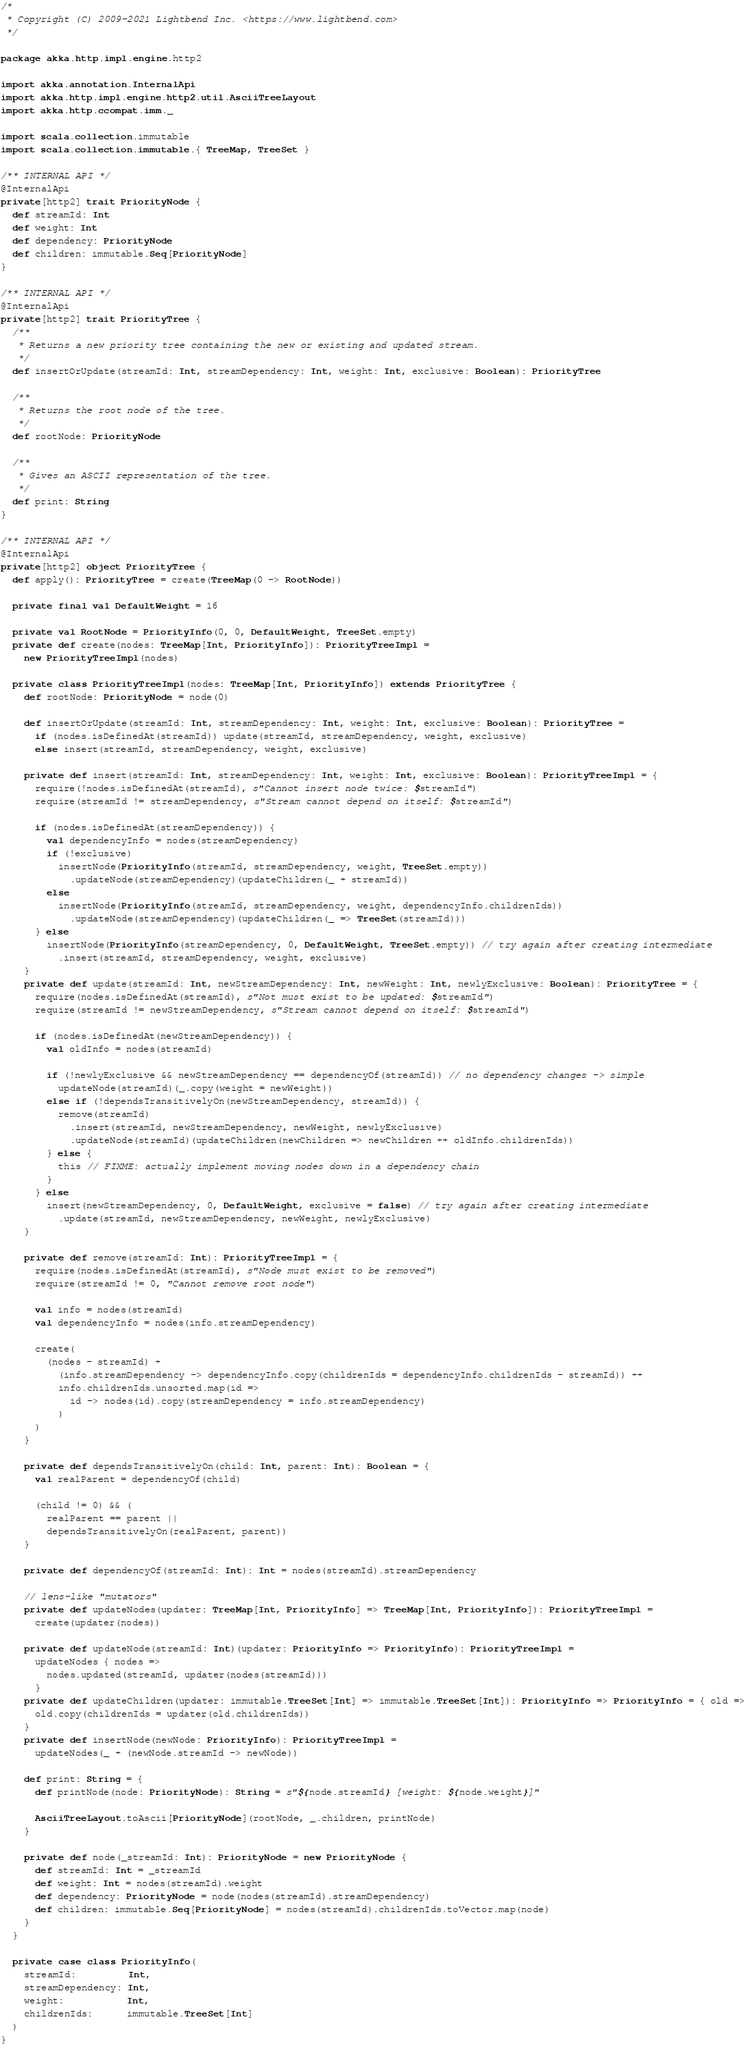<code> <loc_0><loc_0><loc_500><loc_500><_Scala_>/*
 * Copyright (C) 2009-2021 Lightbend Inc. <https://www.lightbend.com>
 */

package akka.http.impl.engine.http2

import akka.annotation.InternalApi
import akka.http.impl.engine.http2.util.AsciiTreeLayout
import akka.http.ccompat.imm._

import scala.collection.immutable
import scala.collection.immutable.{ TreeMap, TreeSet }

/** INTERNAL API */
@InternalApi
private[http2] trait PriorityNode {
  def streamId: Int
  def weight: Int
  def dependency: PriorityNode
  def children: immutable.Seq[PriorityNode]
}

/** INTERNAL API */
@InternalApi
private[http2] trait PriorityTree {
  /**
   * Returns a new priority tree containing the new or existing and updated stream.
   */
  def insertOrUpdate(streamId: Int, streamDependency: Int, weight: Int, exclusive: Boolean): PriorityTree

  /**
   * Returns the root node of the tree.
   */
  def rootNode: PriorityNode

  /**
   * Gives an ASCII representation of the tree.
   */
  def print: String
}

/** INTERNAL API */
@InternalApi
private[http2] object PriorityTree {
  def apply(): PriorityTree = create(TreeMap(0 -> RootNode))

  private final val DefaultWeight = 16

  private val RootNode = PriorityInfo(0, 0, DefaultWeight, TreeSet.empty)
  private def create(nodes: TreeMap[Int, PriorityInfo]): PriorityTreeImpl =
    new PriorityTreeImpl(nodes)

  private class PriorityTreeImpl(nodes: TreeMap[Int, PriorityInfo]) extends PriorityTree {
    def rootNode: PriorityNode = node(0)

    def insertOrUpdate(streamId: Int, streamDependency: Int, weight: Int, exclusive: Boolean): PriorityTree =
      if (nodes.isDefinedAt(streamId)) update(streamId, streamDependency, weight, exclusive)
      else insert(streamId, streamDependency, weight, exclusive)

    private def insert(streamId: Int, streamDependency: Int, weight: Int, exclusive: Boolean): PriorityTreeImpl = {
      require(!nodes.isDefinedAt(streamId), s"Cannot insert node twice: $streamId")
      require(streamId != streamDependency, s"Stream cannot depend on itself: $streamId")

      if (nodes.isDefinedAt(streamDependency)) {
        val dependencyInfo = nodes(streamDependency)
        if (!exclusive)
          insertNode(PriorityInfo(streamId, streamDependency, weight, TreeSet.empty))
            .updateNode(streamDependency)(updateChildren(_ + streamId))
        else
          insertNode(PriorityInfo(streamId, streamDependency, weight, dependencyInfo.childrenIds))
            .updateNode(streamDependency)(updateChildren(_ => TreeSet(streamId)))
      } else
        insertNode(PriorityInfo(streamDependency, 0, DefaultWeight, TreeSet.empty)) // try again after creating intermediate
          .insert(streamId, streamDependency, weight, exclusive)
    }
    private def update(streamId: Int, newStreamDependency: Int, newWeight: Int, newlyExclusive: Boolean): PriorityTree = {
      require(nodes.isDefinedAt(streamId), s"Not must exist to be updated: $streamId")
      require(streamId != newStreamDependency, s"Stream cannot depend on itself: $streamId")

      if (nodes.isDefinedAt(newStreamDependency)) {
        val oldInfo = nodes(streamId)

        if (!newlyExclusive && newStreamDependency == dependencyOf(streamId)) // no dependency changes -> simple
          updateNode(streamId)(_.copy(weight = newWeight))
        else if (!dependsTransitivelyOn(newStreamDependency, streamId)) {
          remove(streamId)
            .insert(streamId, newStreamDependency, newWeight, newlyExclusive)
            .updateNode(streamId)(updateChildren(newChildren => newChildren ++ oldInfo.childrenIds))
        } else {
          this // FIXME: actually implement moving nodes down in a dependency chain
        }
      } else
        insert(newStreamDependency, 0, DefaultWeight, exclusive = false) // try again after creating intermediate
          .update(streamId, newStreamDependency, newWeight, newlyExclusive)
    }

    private def remove(streamId: Int): PriorityTreeImpl = {
      require(nodes.isDefinedAt(streamId), s"Node must exist to be removed")
      require(streamId != 0, "Cannot remove root node")

      val info = nodes(streamId)
      val dependencyInfo = nodes(info.streamDependency)

      create(
        (nodes - streamId) +
          (info.streamDependency -> dependencyInfo.copy(childrenIds = dependencyInfo.childrenIds - streamId)) ++
          info.childrenIds.unsorted.map(id =>
            id -> nodes(id).copy(streamDependency = info.streamDependency)
          )
      )
    }

    private def dependsTransitivelyOn(child: Int, parent: Int): Boolean = {
      val realParent = dependencyOf(child)

      (child != 0) && (
        realParent == parent ||
        dependsTransitivelyOn(realParent, parent))
    }

    private def dependencyOf(streamId: Int): Int = nodes(streamId).streamDependency

    // lens-like "mutators"
    private def updateNodes(updater: TreeMap[Int, PriorityInfo] => TreeMap[Int, PriorityInfo]): PriorityTreeImpl =
      create(updater(nodes))

    private def updateNode(streamId: Int)(updater: PriorityInfo => PriorityInfo): PriorityTreeImpl =
      updateNodes { nodes =>
        nodes.updated(streamId, updater(nodes(streamId)))
      }
    private def updateChildren(updater: immutable.TreeSet[Int] => immutable.TreeSet[Int]): PriorityInfo => PriorityInfo = { old =>
      old.copy(childrenIds = updater(old.childrenIds))
    }
    private def insertNode(newNode: PriorityInfo): PriorityTreeImpl =
      updateNodes(_ + (newNode.streamId -> newNode))

    def print: String = {
      def printNode(node: PriorityNode): String = s"${node.streamId} [weight: ${node.weight}]"

      AsciiTreeLayout.toAscii[PriorityNode](rootNode, _.children, printNode)
    }

    private def node(_streamId: Int): PriorityNode = new PriorityNode {
      def streamId: Int = _streamId
      def weight: Int = nodes(streamId).weight
      def dependency: PriorityNode = node(nodes(streamId).streamDependency)
      def children: immutable.Seq[PriorityNode] = nodes(streamId).childrenIds.toVector.map(node)
    }
  }

  private case class PriorityInfo(
    streamId:         Int,
    streamDependency: Int,
    weight:           Int,
    childrenIds:      immutable.TreeSet[Int]
  )
}
</code> 